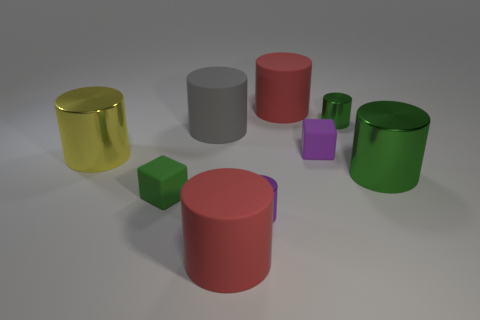What is the largest object in this collection? The largest object in the image is the red cylinder located near the center. Its height and overall size are greater than those of the other objects. 